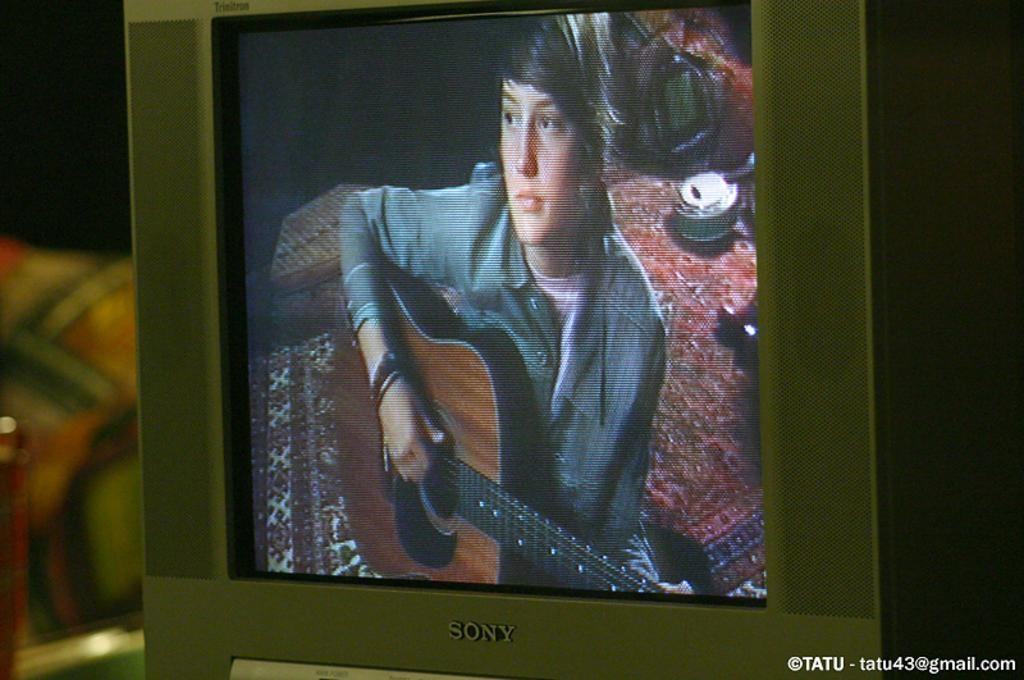<image>
Present a compact description of the photo's key features. A person playing guitar is on a Sony tv screen. 